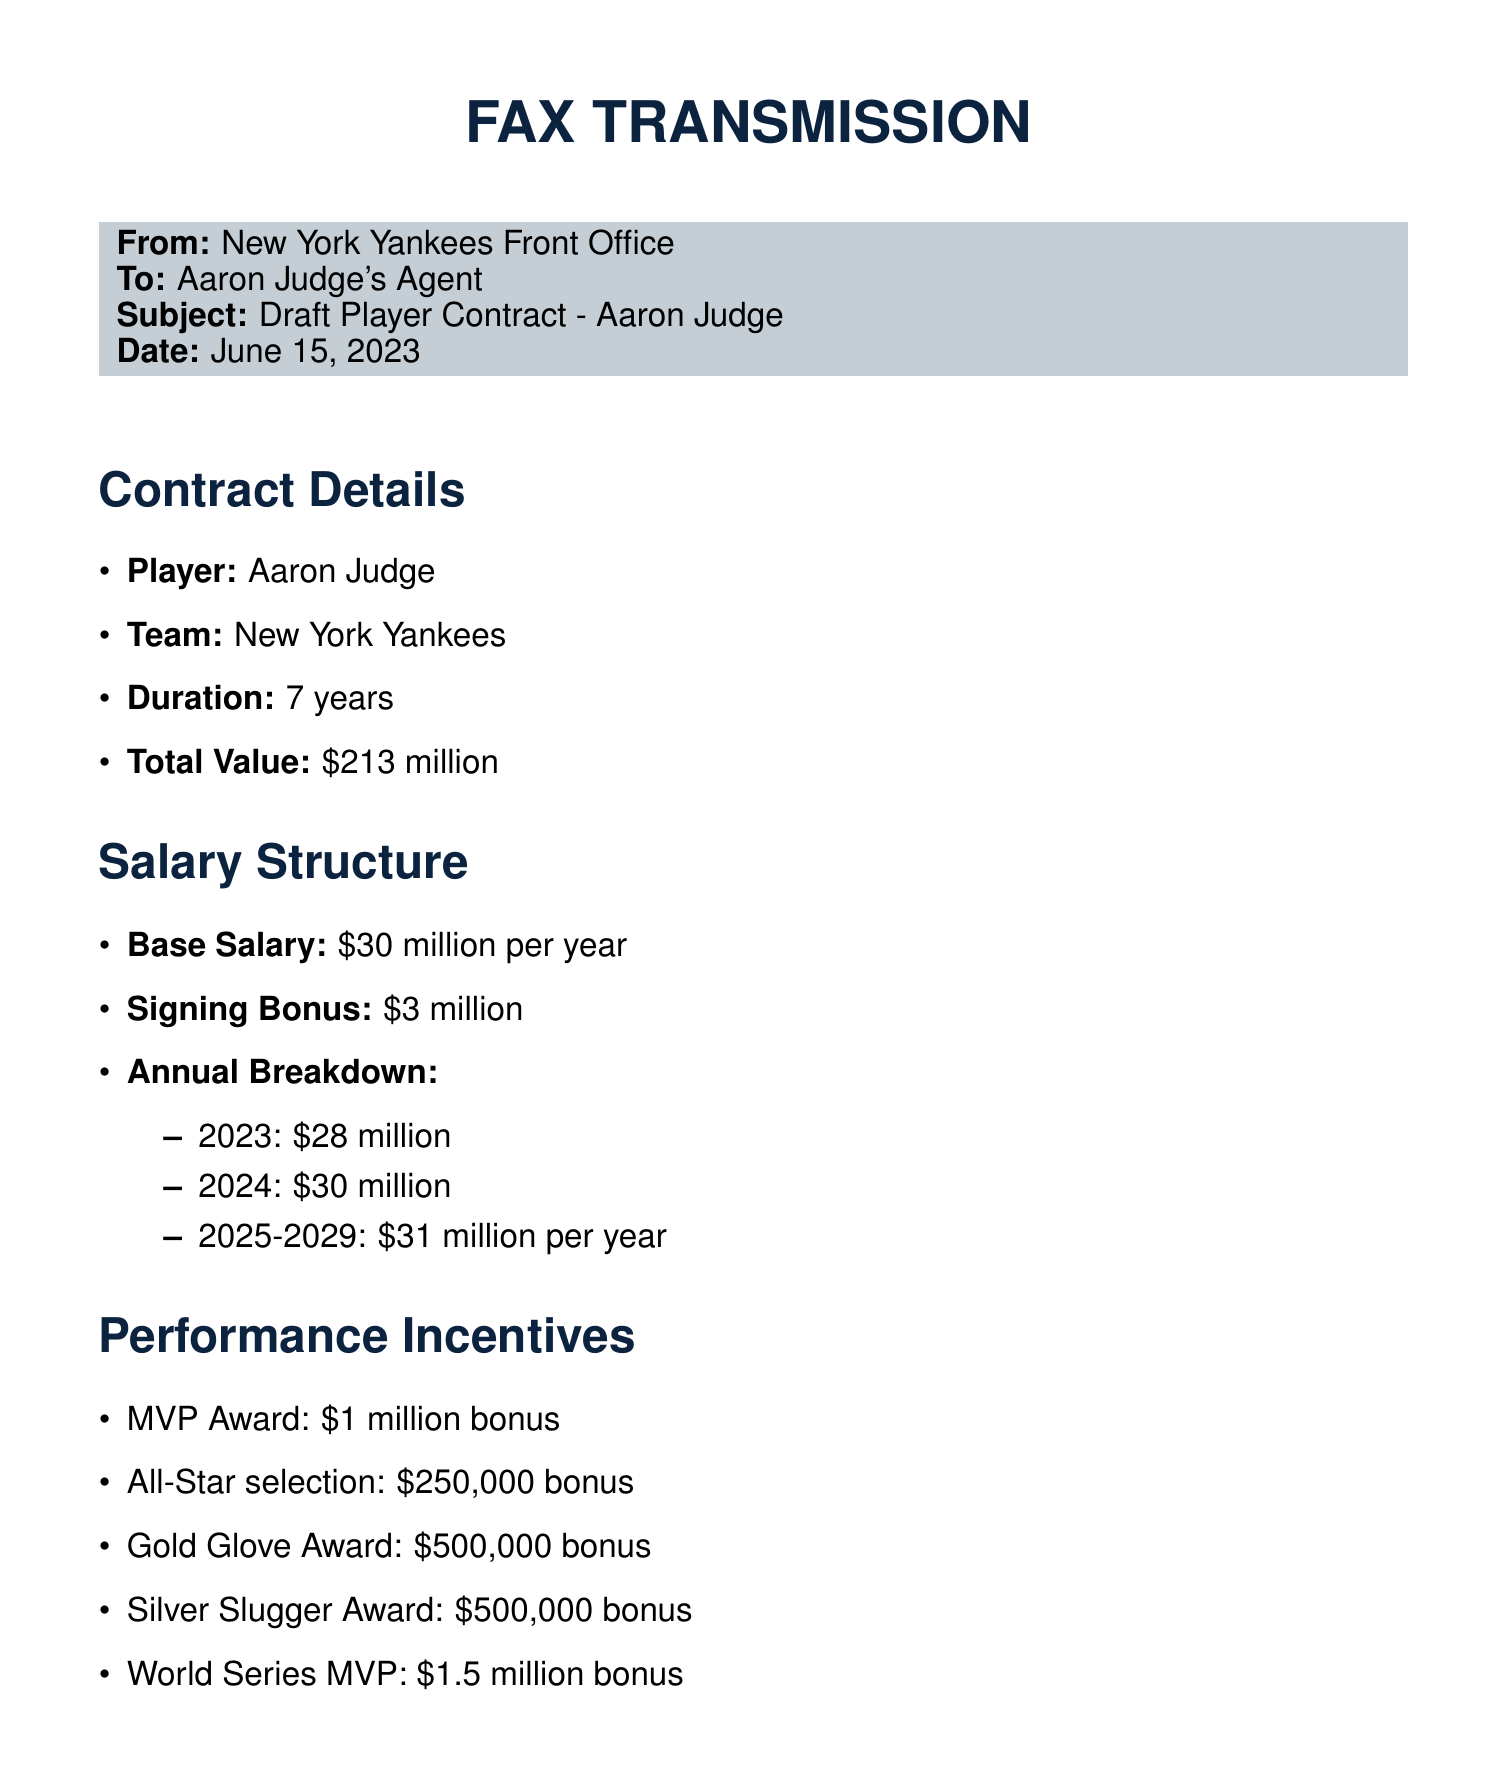What is the player's name? The player's name mentioned in the document is Aaron Judge.
Answer: Aaron Judge What is the total value of the contract? The total value of the contract according to the document is specified as $213 million.
Answer: $213 million How long is the contract duration? The duration of the contract stated in the document is for 7 years.
Answer: 7 years What is the signing bonus amount? The signing bonus outlined in the contract is $3 million.
Answer: $3 million What is the base salary for the second year? The document specifies the base salary for the second year (2024) as $30 million.
Answer: $30 million How much does the player receive for an MVP Award? According to the performance incentives listed, the player receives a bonus of $1 million for winning the MVP Award.
Answer: $1 million What is the bonus for an All-Star selection? The document states that the bonus for an All-Star selection is $250,000.
Answer: $250,000 What option does the player have after the fifth year? The contract provides a player option after the fifth year.
Answer: Player option What is the annual charitable donation requirement? The document indicates that the annual charitable donation requirement is $500,000.
Answer: $500,000 